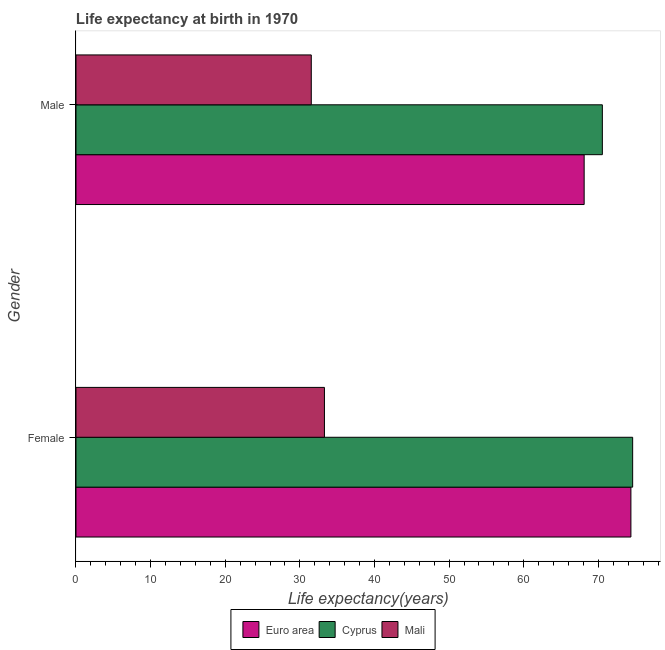How many groups of bars are there?
Provide a short and direct response. 2. How many bars are there on the 2nd tick from the top?
Offer a very short reply. 3. How many bars are there on the 2nd tick from the bottom?
Make the answer very short. 3. What is the label of the 1st group of bars from the top?
Your response must be concise. Male. What is the life expectancy(female) in Mali?
Ensure brevity in your answer.  33.3. Across all countries, what is the maximum life expectancy(male)?
Keep it short and to the point. 70.54. Across all countries, what is the minimum life expectancy(female)?
Make the answer very short. 33.3. In which country was the life expectancy(female) maximum?
Provide a succinct answer. Cyprus. In which country was the life expectancy(male) minimum?
Provide a short and direct response. Mali. What is the total life expectancy(female) in the graph?
Your answer should be compact. 182.27. What is the difference between the life expectancy(male) in Euro area and that in Mali?
Offer a terse response. 36.57. What is the difference between the life expectancy(male) in Cyprus and the life expectancy(female) in Euro area?
Your answer should be compact. -3.83. What is the average life expectancy(male) per country?
Provide a succinct answer. 56.73. What is the difference between the life expectancy(female) and life expectancy(male) in Mali?
Offer a terse response. 1.76. What is the ratio of the life expectancy(male) in Euro area to that in Cyprus?
Offer a terse response. 0.97. In how many countries, is the life expectancy(male) greater than the average life expectancy(male) taken over all countries?
Your response must be concise. 2. What does the 2nd bar from the top in Male represents?
Ensure brevity in your answer.  Cyprus. What does the 3rd bar from the bottom in Female represents?
Give a very brief answer. Mali. Are all the bars in the graph horizontal?
Provide a short and direct response. Yes. Are the values on the major ticks of X-axis written in scientific E-notation?
Keep it short and to the point. No. Does the graph contain grids?
Offer a very short reply. No. Where does the legend appear in the graph?
Offer a terse response. Bottom center. How many legend labels are there?
Make the answer very short. 3. What is the title of the graph?
Give a very brief answer. Life expectancy at birth in 1970. Does "Angola" appear as one of the legend labels in the graph?
Keep it short and to the point. No. What is the label or title of the X-axis?
Give a very brief answer. Life expectancy(years). What is the Life expectancy(years) in Euro area in Female?
Provide a short and direct response. 74.37. What is the Life expectancy(years) of Cyprus in Female?
Keep it short and to the point. 74.6. What is the Life expectancy(years) of Mali in Female?
Keep it short and to the point. 33.3. What is the Life expectancy(years) of Euro area in Male?
Provide a short and direct response. 68.1. What is the Life expectancy(years) of Cyprus in Male?
Your answer should be very brief. 70.54. What is the Life expectancy(years) of Mali in Male?
Provide a succinct answer. 31.53. Across all Gender, what is the maximum Life expectancy(years) of Euro area?
Your answer should be very brief. 74.37. Across all Gender, what is the maximum Life expectancy(years) in Cyprus?
Give a very brief answer. 74.6. Across all Gender, what is the maximum Life expectancy(years) of Mali?
Ensure brevity in your answer.  33.3. Across all Gender, what is the minimum Life expectancy(years) in Euro area?
Ensure brevity in your answer.  68.1. Across all Gender, what is the minimum Life expectancy(years) of Cyprus?
Give a very brief answer. 70.54. Across all Gender, what is the minimum Life expectancy(years) in Mali?
Make the answer very short. 31.53. What is the total Life expectancy(years) in Euro area in the graph?
Provide a succinct answer. 142.47. What is the total Life expectancy(years) in Cyprus in the graph?
Your answer should be compact. 145.15. What is the total Life expectancy(years) in Mali in the graph?
Give a very brief answer. 64.83. What is the difference between the Life expectancy(years) in Euro area in Female and that in Male?
Your response must be concise. 6.27. What is the difference between the Life expectancy(years) of Cyprus in Female and that in Male?
Provide a short and direct response. 4.06. What is the difference between the Life expectancy(years) of Mali in Female and that in Male?
Provide a short and direct response. 1.76. What is the difference between the Life expectancy(years) in Euro area in Female and the Life expectancy(years) in Cyprus in Male?
Provide a short and direct response. 3.83. What is the difference between the Life expectancy(years) of Euro area in Female and the Life expectancy(years) of Mali in Male?
Provide a short and direct response. 42.83. What is the difference between the Life expectancy(years) of Cyprus in Female and the Life expectancy(years) of Mali in Male?
Provide a succinct answer. 43.07. What is the average Life expectancy(years) in Euro area per Gender?
Offer a very short reply. 71.23. What is the average Life expectancy(years) of Cyprus per Gender?
Provide a succinct answer. 72.57. What is the average Life expectancy(years) of Mali per Gender?
Offer a terse response. 32.41. What is the difference between the Life expectancy(years) of Euro area and Life expectancy(years) of Cyprus in Female?
Provide a short and direct response. -0.24. What is the difference between the Life expectancy(years) in Euro area and Life expectancy(years) in Mali in Female?
Ensure brevity in your answer.  41.07. What is the difference between the Life expectancy(years) in Cyprus and Life expectancy(years) in Mali in Female?
Keep it short and to the point. 41.31. What is the difference between the Life expectancy(years) of Euro area and Life expectancy(years) of Cyprus in Male?
Your answer should be compact. -2.44. What is the difference between the Life expectancy(years) of Euro area and Life expectancy(years) of Mali in Male?
Offer a terse response. 36.57. What is the difference between the Life expectancy(years) of Cyprus and Life expectancy(years) of Mali in Male?
Offer a terse response. 39.01. What is the ratio of the Life expectancy(years) in Euro area in Female to that in Male?
Your response must be concise. 1.09. What is the ratio of the Life expectancy(years) in Cyprus in Female to that in Male?
Your answer should be compact. 1.06. What is the ratio of the Life expectancy(years) in Mali in Female to that in Male?
Your response must be concise. 1.06. What is the difference between the highest and the second highest Life expectancy(years) in Euro area?
Provide a succinct answer. 6.27. What is the difference between the highest and the second highest Life expectancy(years) in Cyprus?
Provide a succinct answer. 4.06. What is the difference between the highest and the second highest Life expectancy(years) of Mali?
Ensure brevity in your answer.  1.76. What is the difference between the highest and the lowest Life expectancy(years) of Euro area?
Give a very brief answer. 6.27. What is the difference between the highest and the lowest Life expectancy(years) of Cyprus?
Offer a terse response. 4.06. What is the difference between the highest and the lowest Life expectancy(years) in Mali?
Provide a short and direct response. 1.76. 